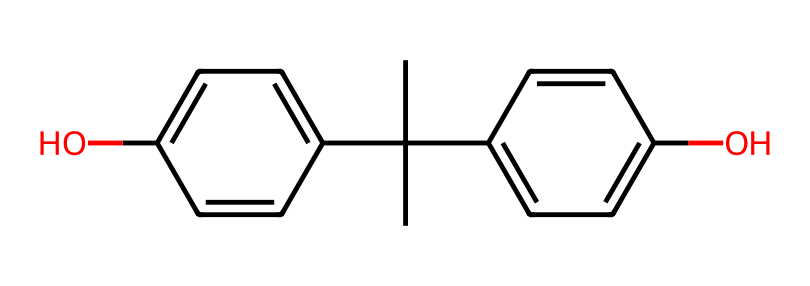What is the molecular formula of bisphenol A? The chemical structure shows that it is composed of 15 carbons (C), 16 hydrogens (H), and 2 oxygens (O), leading to the molecular formula C15H16O2.
Answer: C15H16O2 How many hydroxyl (–OH) groups are present? The structure contains two –OH groups, indicated by the presence of two oxygen atoms bonded to hydrogen atoms in the chemical structure.
Answer: 2 What is the type of chemical bond primarily found in bisphenol A? Bisphenol A contains numerous carbon-carbon and carbon-oxygen bonds, but the prevalent bond type visible is covalent, as it connects the atoms in the structure.
Answer: covalent What does the presence of phenolic –OH groups imply about bisphenol A? The –OH groups attached to the aromatic rings indicate that bisphenol A is a phenolic compound, suggesting properties such as potential reactivity in chemical processes and characteristic behavior in biological systems.
Answer: phenolic compound What is a key health risk associated with bisphenol A exposure? Bisphenol A is associated with endocrine disruption, which means it can interfere with hormonal functions in the body, leading to various health issues.
Answer: endocrine disruption How does the structure of bisphenol A relate to its industrial use? The presence of multiple phenolic groups and their covalent linkages contribute to the heat resistance and rigidity of plastics and resins, making bisphenol A valuable in industrial applications for manufacturing materials like polycarbonate and epoxies.
Answer: industrial plastics and resins 